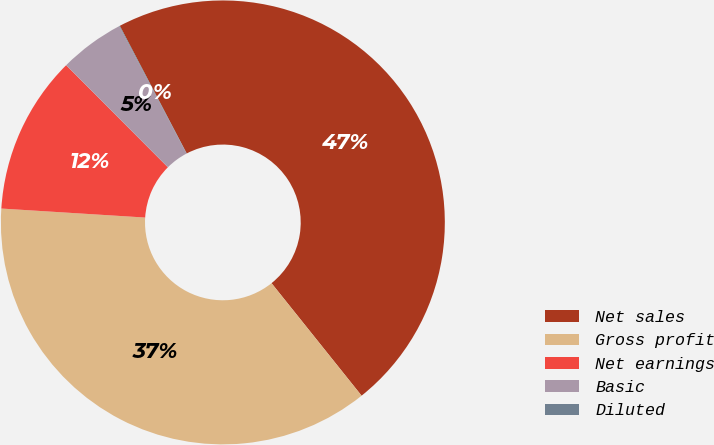<chart> <loc_0><loc_0><loc_500><loc_500><pie_chart><fcel>Net sales<fcel>Gross profit<fcel>Net earnings<fcel>Basic<fcel>Diluted<nl><fcel>46.94%<fcel>36.74%<fcel>11.53%<fcel>4.74%<fcel>0.05%<nl></chart> 